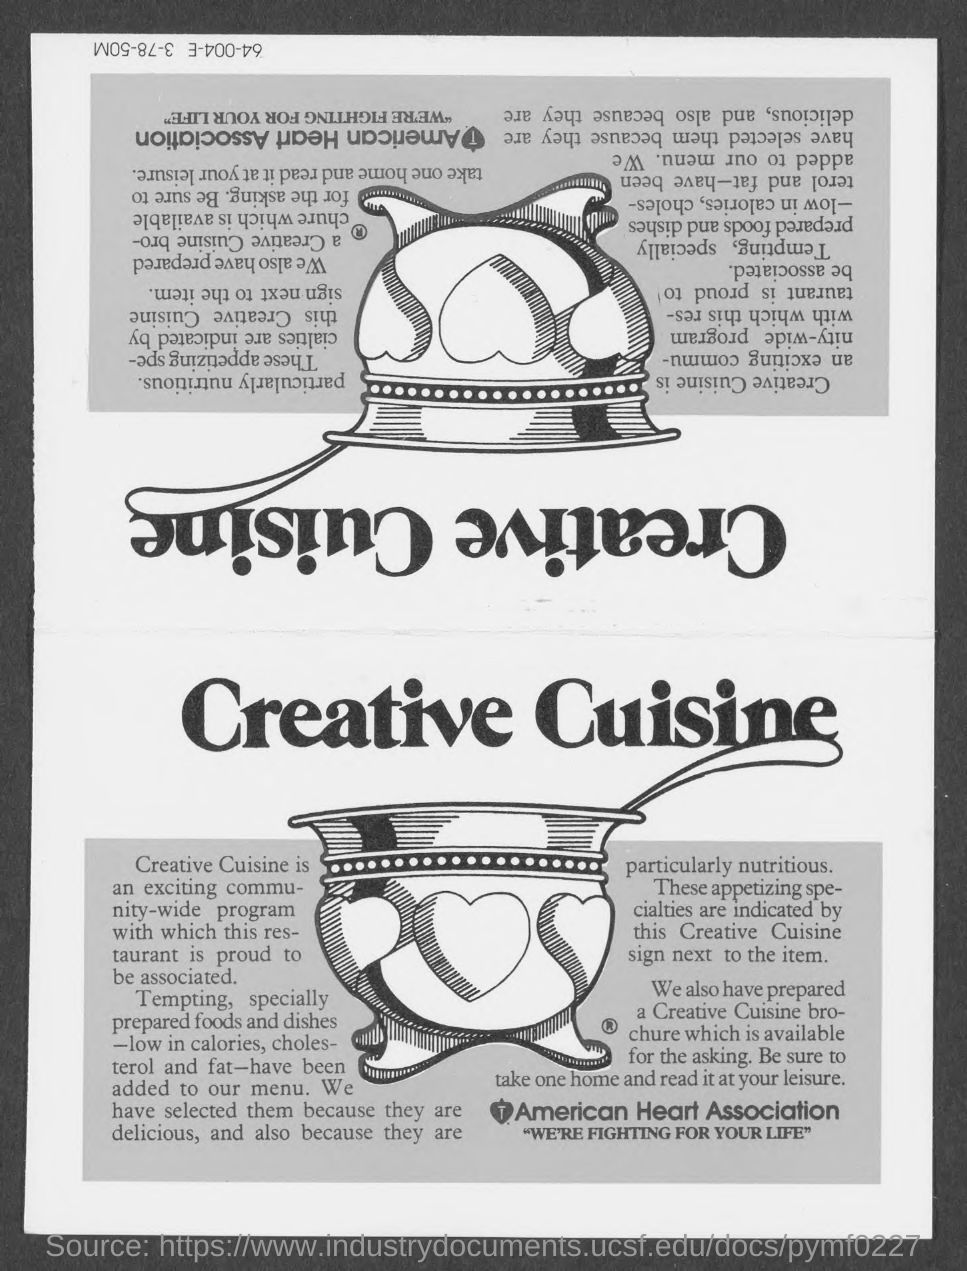What is the name of heart association ?
Provide a short and direct response. American heart association. What is the heading of the page?
Your answer should be compact. Creative Cuisine. What is the tagline of american heart association in quotes ?
Provide a succinct answer. "we're fighting for your life". 